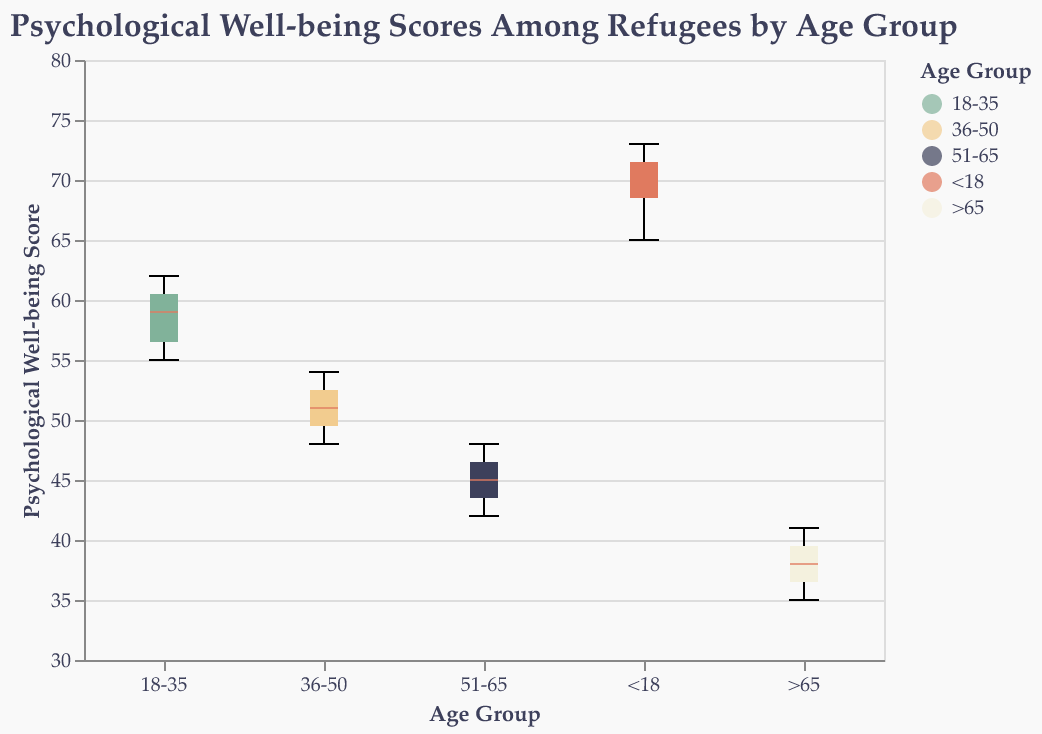What is the median psychological well-being score for refugees aged 36-50? To find the median score for the age group 36-50, look at the box plot for this group and identify the line inside the box, which represents the median score.
Answer: 51 Which age group has the highest median psychological well-being score? Compare the median lines (the small line within the boxes) of all age groups. The age group with the highest median line is the one with the highest median score.
Answer: <18 What is the interquartile range (IQR) for the age group 51-65? To find the IQR, identify the bottom and top edges of the box for the age group 51-65. The IQR is the difference between these two values. The bottom edge (Q1) represents the 25th percentile, and the top edge (Q3) represents the 75th percentile.
Answer: 5 (from 43 to 48) Which age group shows the least variation in psychological well-being scores? Variation in scores can be judged by the size of the box (the interquartile range). The age group with the smallest box displays the least variation in their scores.
Answer: >65 Are there any significant overlaps in the psychological well-being scores between the age groups <18 and 18-35? Examine the notches of the box plots for these two age groups. If the notches of two groups overlap, there is no statistically significant difference between their medians.
Answer: No Which age group has the lowest maximum psychological well-being score? Look at the top whiskers of each box plot to identify the maximum score for each age group. The group with the lowest position of the top whisker has the lowest maximum score.
Answer: >65 What is the range of scores for the age group 18-35? The range is the difference between the maximum and minimum values. Identify the top and bottom whiskers for the age group 18-35 to find the range.
Answer: 55 to 62 How do the median scores compare between age groups <18 and 51-65? Identify the median lines for both age groups and compare their positions to determine which is higher.
Answer: The median is higher for <18 What percentage of psychological well-being scores fall below the median for refugees aged 36-50? By definition, the median divides the data into two equal halves. Therefore, 50% of the data falls below the median.
Answer: 50% Is the data for any age group skewed, and if so, how can you tell? Skewness in the data can be identified if the median line is not centered within the box, or if the whiskers are not balanced. Checking the symmetry of the box plots for each age group can determine skewness.
Answer: Yes, age group 18-35 is slightly skewed to the right 